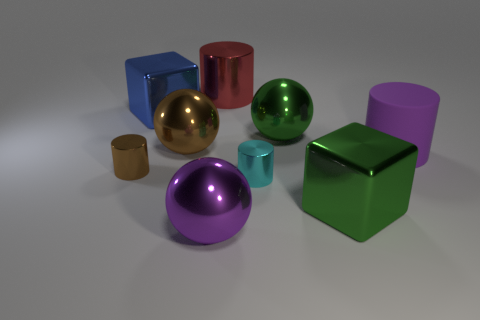What number of cylinders are tiny yellow objects or cyan objects?
Make the answer very short. 1. Does the large red object have the same shape as the tiny thing to the left of the tiny cyan shiny cylinder?
Ensure brevity in your answer.  Yes. How many blue metal objects have the same size as the blue cube?
Give a very brief answer. 0. There is a big green object behind the purple matte cylinder; is its shape the same as the big purple object that is to the left of the purple matte cylinder?
Your answer should be compact. Yes. There is a object that is the same color as the rubber cylinder; what is its shape?
Your response must be concise. Sphere. There is a big object in front of the green object on the right side of the green metallic ball; what color is it?
Ensure brevity in your answer.  Purple. The other metal object that is the same shape as the blue metallic object is what color?
Keep it short and to the point. Green. Are there any other things that are the same material as the big red cylinder?
Provide a succinct answer. Yes. The brown thing that is the same shape as the cyan metal thing is what size?
Your answer should be compact. Small. What is the material of the sphere in front of the large purple matte thing?
Provide a succinct answer. Metal. 